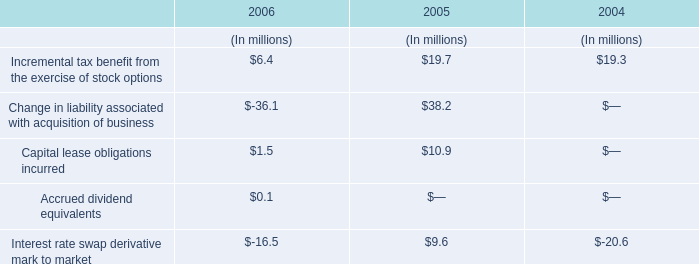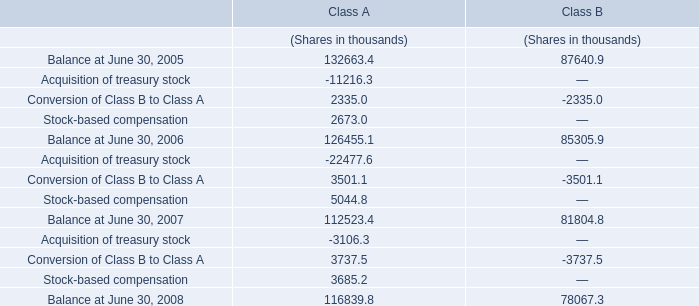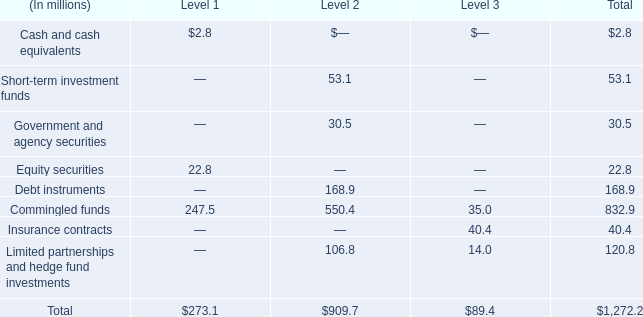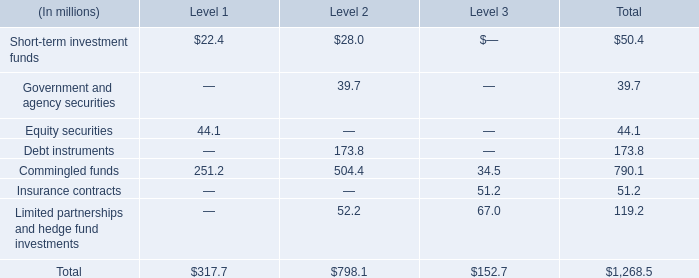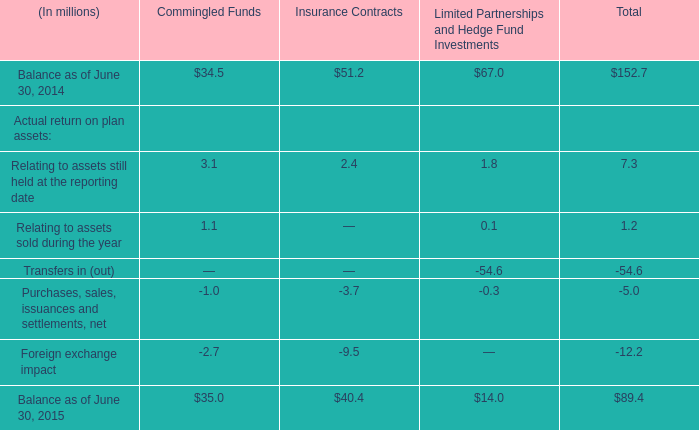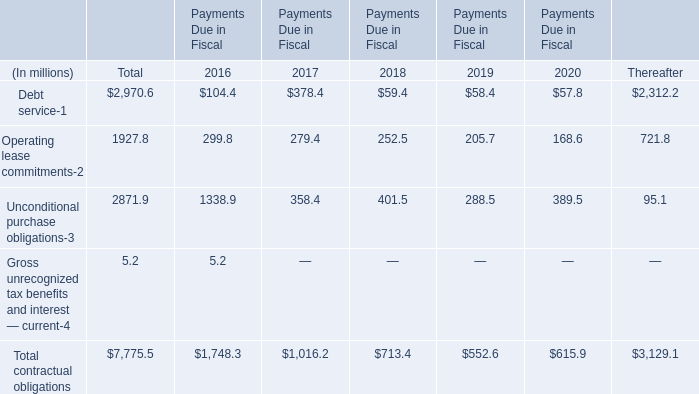In what sections is Commingled funds greater than 500? 
Answer: Level 2. 